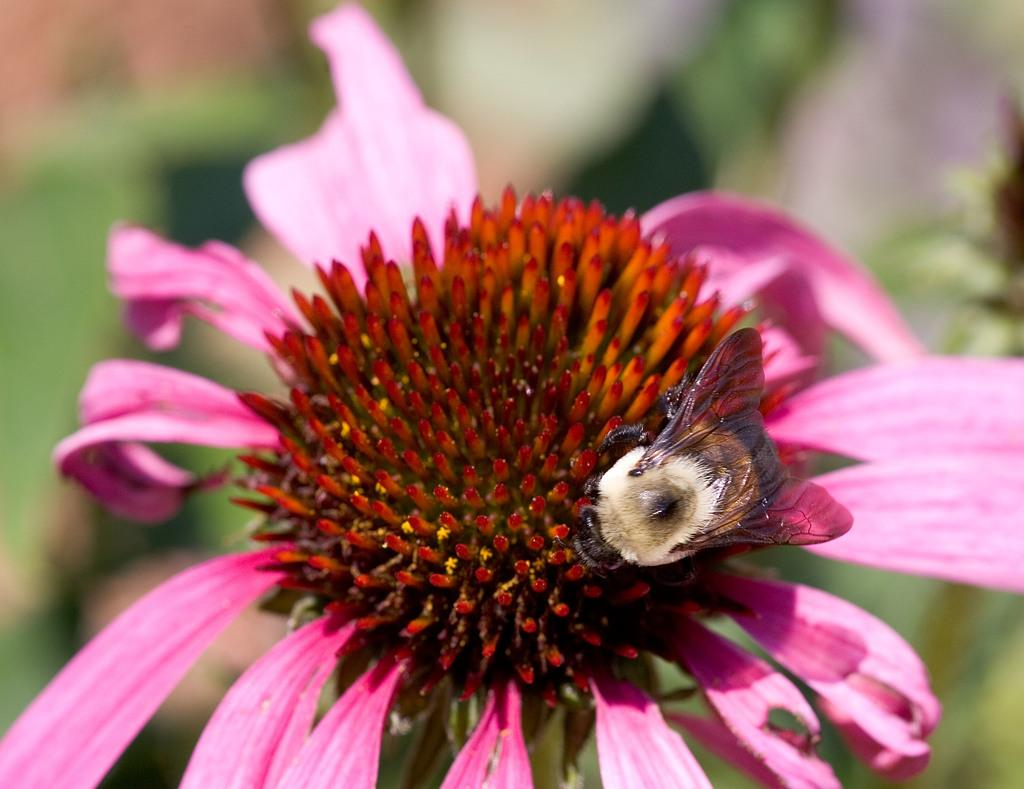What is the main subject of the picture? The main subject of the picture is an insect. Where is the insect located in the image? The insect is on a flower. Can you describe the background of the image? The background of the image is blurred. What type of bun is the insect holding in the image? There is no bun present in the image; it features an insect on a flower. How is the egg connected to the insect in the image? There is no egg present in the image, and therefore no connection can be observed between the insect and an egg. 